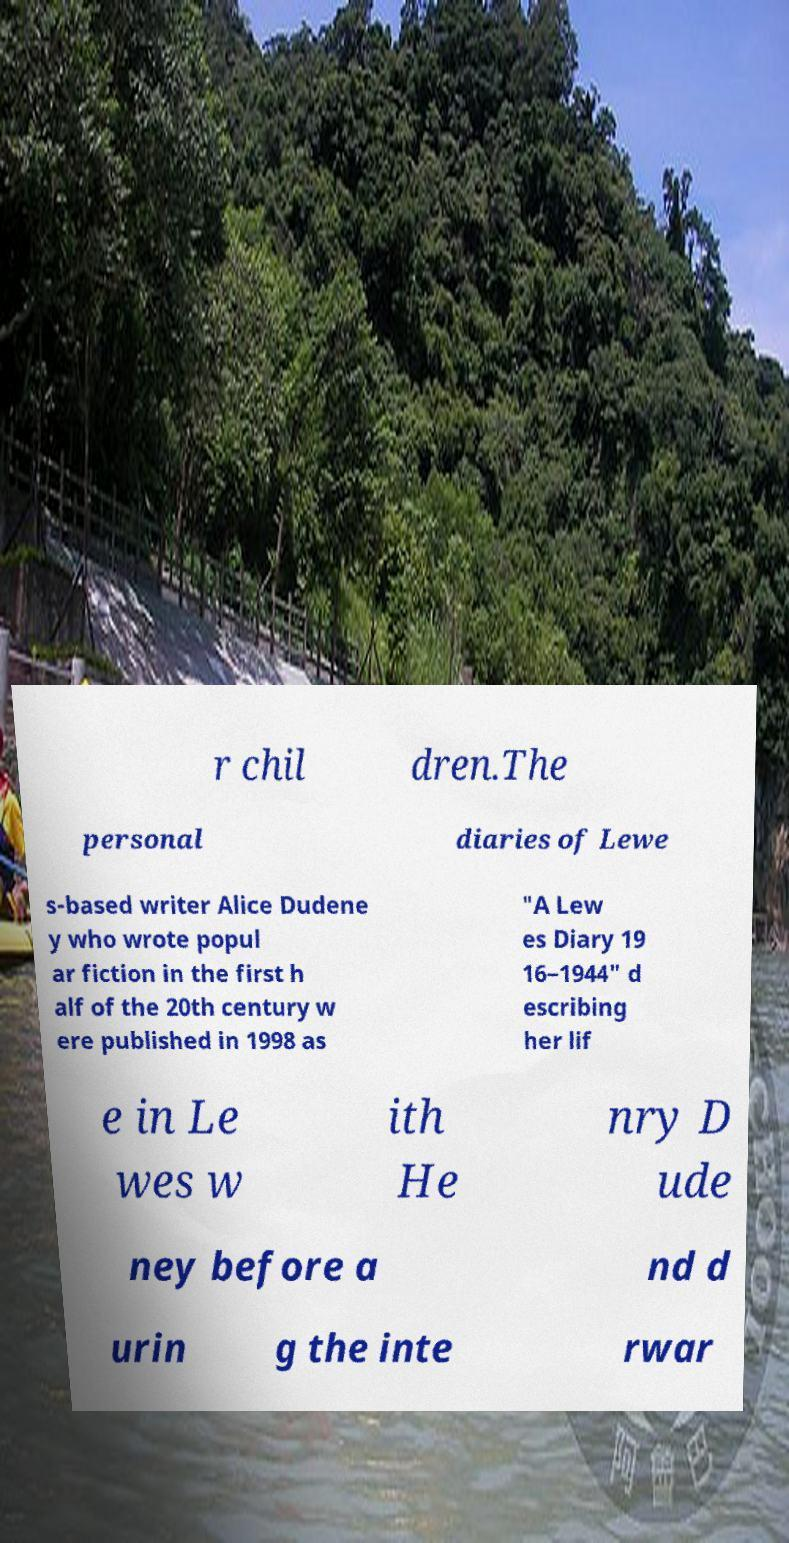What messages or text are displayed in this image? I need them in a readable, typed format. r chil dren.The personal diaries of Lewe s-based writer Alice Dudene y who wrote popul ar fiction in the first h alf of the 20th century w ere published in 1998 as "A Lew es Diary 19 16–1944" d escribing her lif e in Le wes w ith He nry D ude ney before a nd d urin g the inte rwar 